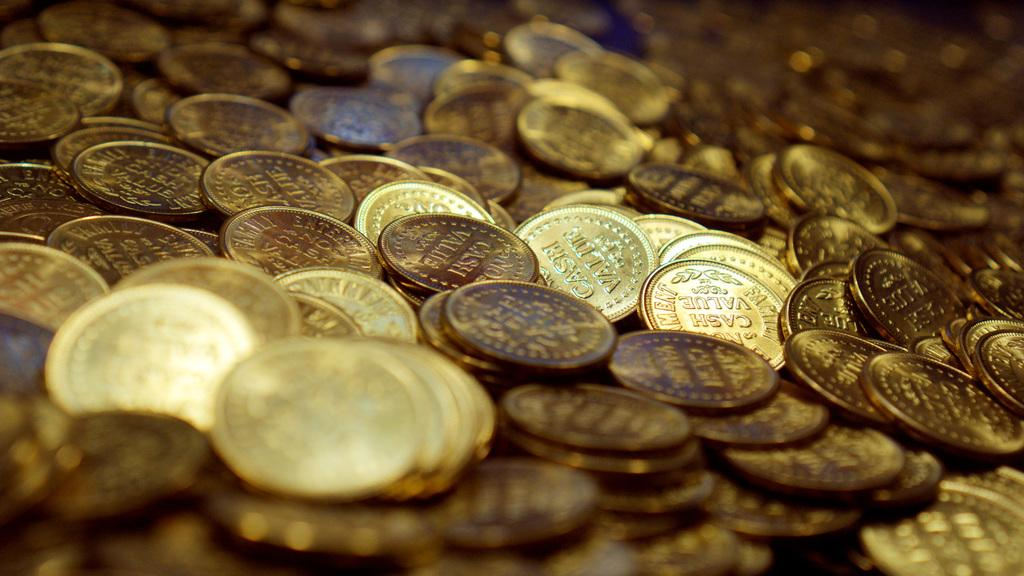<image>
Render a clear and concise summary of the photo. Many coins on a table including one that says CASH on it. 